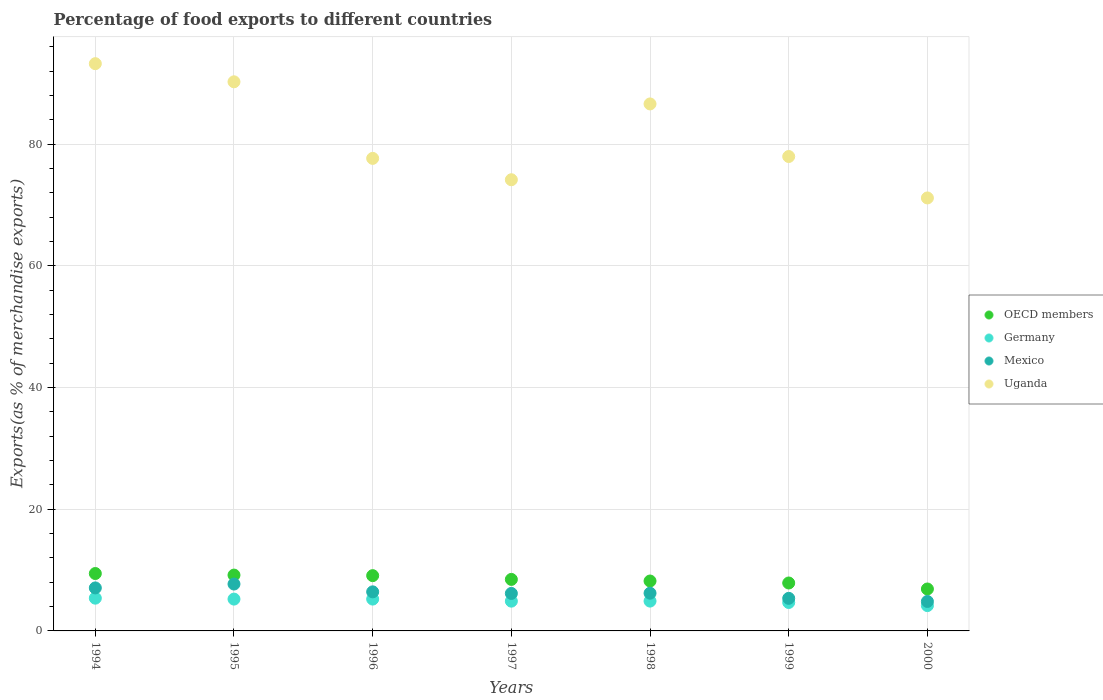How many different coloured dotlines are there?
Your response must be concise. 4. What is the percentage of exports to different countries in Germany in 2000?
Provide a succinct answer. 4.16. Across all years, what is the maximum percentage of exports to different countries in Germany?
Offer a very short reply. 5.38. Across all years, what is the minimum percentage of exports to different countries in Germany?
Offer a terse response. 4.16. What is the total percentage of exports to different countries in OECD members in the graph?
Provide a succinct answer. 59.15. What is the difference between the percentage of exports to different countries in OECD members in 1996 and that in 1998?
Keep it short and to the point. 0.88. What is the difference between the percentage of exports to different countries in Uganda in 1995 and the percentage of exports to different countries in OECD members in 2000?
Ensure brevity in your answer.  83.38. What is the average percentage of exports to different countries in Germany per year?
Keep it short and to the point. 4.93. In the year 1994, what is the difference between the percentage of exports to different countries in Germany and percentage of exports to different countries in Uganda?
Your answer should be compact. -87.87. In how many years, is the percentage of exports to different countries in Mexico greater than 92 %?
Ensure brevity in your answer.  0. What is the ratio of the percentage of exports to different countries in OECD members in 1996 to that in 1999?
Your answer should be compact. 1.15. What is the difference between the highest and the second highest percentage of exports to different countries in OECD members?
Your answer should be compact. 0.26. What is the difference between the highest and the lowest percentage of exports to different countries in OECD members?
Provide a succinct answer. 2.54. In how many years, is the percentage of exports to different countries in Germany greater than the average percentage of exports to different countries in Germany taken over all years?
Give a very brief answer. 3. Is it the case that in every year, the sum of the percentage of exports to different countries in OECD members and percentage of exports to different countries in Uganda  is greater than the sum of percentage of exports to different countries in Germany and percentage of exports to different countries in Mexico?
Provide a succinct answer. No. Is the percentage of exports to different countries in Mexico strictly greater than the percentage of exports to different countries in OECD members over the years?
Keep it short and to the point. No. Is the percentage of exports to different countries in OECD members strictly less than the percentage of exports to different countries in Uganda over the years?
Offer a very short reply. Yes. How many dotlines are there?
Provide a succinct answer. 4. How many years are there in the graph?
Provide a succinct answer. 7. What is the difference between two consecutive major ticks on the Y-axis?
Keep it short and to the point. 20. Does the graph contain any zero values?
Your answer should be very brief. No. How many legend labels are there?
Keep it short and to the point. 4. What is the title of the graph?
Provide a short and direct response. Percentage of food exports to different countries. What is the label or title of the X-axis?
Offer a terse response. Years. What is the label or title of the Y-axis?
Your answer should be compact. Exports(as % of merchandise exports). What is the Exports(as % of merchandise exports) in OECD members in 1994?
Provide a short and direct response. 9.44. What is the Exports(as % of merchandise exports) in Germany in 1994?
Your answer should be compact. 5.38. What is the Exports(as % of merchandise exports) in Mexico in 1994?
Your answer should be compact. 7.07. What is the Exports(as % of merchandise exports) in Uganda in 1994?
Provide a succinct answer. 93.25. What is the Exports(as % of merchandise exports) of OECD members in 1995?
Give a very brief answer. 9.18. What is the Exports(as % of merchandise exports) in Germany in 1995?
Ensure brevity in your answer.  5.23. What is the Exports(as % of merchandise exports) in Mexico in 1995?
Offer a very short reply. 7.71. What is the Exports(as % of merchandise exports) in Uganda in 1995?
Provide a short and direct response. 90.27. What is the Exports(as % of merchandise exports) in OECD members in 1996?
Provide a succinct answer. 9.09. What is the Exports(as % of merchandise exports) of Germany in 1996?
Provide a succinct answer. 5.23. What is the Exports(as % of merchandise exports) in Mexico in 1996?
Your answer should be very brief. 6.42. What is the Exports(as % of merchandise exports) of Uganda in 1996?
Give a very brief answer. 77.68. What is the Exports(as % of merchandise exports) of OECD members in 1997?
Ensure brevity in your answer.  8.47. What is the Exports(as % of merchandise exports) in Germany in 1997?
Make the answer very short. 4.89. What is the Exports(as % of merchandise exports) in Mexico in 1997?
Provide a succinct answer. 6.16. What is the Exports(as % of merchandise exports) in Uganda in 1997?
Ensure brevity in your answer.  74.17. What is the Exports(as % of merchandise exports) of OECD members in 1998?
Give a very brief answer. 8.2. What is the Exports(as % of merchandise exports) of Germany in 1998?
Ensure brevity in your answer.  4.9. What is the Exports(as % of merchandise exports) of Mexico in 1998?
Provide a succinct answer. 6.2. What is the Exports(as % of merchandise exports) of Uganda in 1998?
Keep it short and to the point. 86.64. What is the Exports(as % of merchandise exports) in OECD members in 1999?
Provide a succinct answer. 7.88. What is the Exports(as % of merchandise exports) of Germany in 1999?
Give a very brief answer. 4.67. What is the Exports(as % of merchandise exports) of Mexico in 1999?
Your response must be concise. 5.36. What is the Exports(as % of merchandise exports) in Uganda in 1999?
Your response must be concise. 77.99. What is the Exports(as % of merchandise exports) of OECD members in 2000?
Provide a short and direct response. 6.89. What is the Exports(as % of merchandise exports) of Germany in 2000?
Offer a very short reply. 4.16. What is the Exports(as % of merchandise exports) of Mexico in 2000?
Keep it short and to the point. 4.84. What is the Exports(as % of merchandise exports) of Uganda in 2000?
Give a very brief answer. 71.18. Across all years, what is the maximum Exports(as % of merchandise exports) of OECD members?
Your answer should be compact. 9.44. Across all years, what is the maximum Exports(as % of merchandise exports) in Germany?
Your response must be concise. 5.38. Across all years, what is the maximum Exports(as % of merchandise exports) in Mexico?
Give a very brief answer. 7.71. Across all years, what is the maximum Exports(as % of merchandise exports) in Uganda?
Your answer should be very brief. 93.25. Across all years, what is the minimum Exports(as % of merchandise exports) of OECD members?
Offer a very short reply. 6.89. Across all years, what is the minimum Exports(as % of merchandise exports) of Germany?
Keep it short and to the point. 4.16. Across all years, what is the minimum Exports(as % of merchandise exports) of Mexico?
Provide a succinct answer. 4.84. Across all years, what is the minimum Exports(as % of merchandise exports) in Uganda?
Ensure brevity in your answer.  71.18. What is the total Exports(as % of merchandise exports) of OECD members in the graph?
Ensure brevity in your answer.  59.15. What is the total Exports(as % of merchandise exports) in Germany in the graph?
Provide a short and direct response. 34.48. What is the total Exports(as % of merchandise exports) of Mexico in the graph?
Give a very brief answer. 43.76. What is the total Exports(as % of merchandise exports) in Uganda in the graph?
Offer a very short reply. 571.19. What is the difference between the Exports(as % of merchandise exports) in OECD members in 1994 and that in 1995?
Offer a very short reply. 0.26. What is the difference between the Exports(as % of merchandise exports) in Germany in 1994 and that in 1995?
Keep it short and to the point. 0.15. What is the difference between the Exports(as % of merchandise exports) of Mexico in 1994 and that in 1995?
Make the answer very short. -0.64. What is the difference between the Exports(as % of merchandise exports) of Uganda in 1994 and that in 1995?
Ensure brevity in your answer.  2.98. What is the difference between the Exports(as % of merchandise exports) in OECD members in 1994 and that in 1996?
Provide a short and direct response. 0.35. What is the difference between the Exports(as % of merchandise exports) in Germany in 1994 and that in 1996?
Ensure brevity in your answer.  0.15. What is the difference between the Exports(as % of merchandise exports) of Mexico in 1994 and that in 1996?
Ensure brevity in your answer.  0.65. What is the difference between the Exports(as % of merchandise exports) of Uganda in 1994 and that in 1996?
Provide a succinct answer. 15.57. What is the difference between the Exports(as % of merchandise exports) of OECD members in 1994 and that in 1997?
Your answer should be very brief. 0.97. What is the difference between the Exports(as % of merchandise exports) of Germany in 1994 and that in 1997?
Keep it short and to the point. 0.49. What is the difference between the Exports(as % of merchandise exports) of Mexico in 1994 and that in 1997?
Provide a short and direct response. 0.91. What is the difference between the Exports(as % of merchandise exports) of Uganda in 1994 and that in 1997?
Offer a terse response. 19.08. What is the difference between the Exports(as % of merchandise exports) in OECD members in 1994 and that in 1998?
Offer a very short reply. 1.23. What is the difference between the Exports(as % of merchandise exports) in Germany in 1994 and that in 1998?
Make the answer very short. 0.48. What is the difference between the Exports(as % of merchandise exports) in Mexico in 1994 and that in 1998?
Ensure brevity in your answer.  0.87. What is the difference between the Exports(as % of merchandise exports) of Uganda in 1994 and that in 1998?
Keep it short and to the point. 6.62. What is the difference between the Exports(as % of merchandise exports) of OECD members in 1994 and that in 1999?
Provide a succinct answer. 1.56. What is the difference between the Exports(as % of merchandise exports) in Germany in 1994 and that in 1999?
Ensure brevity in your answer.  0.71. What is the difference between the Exports(as % of merchandise exports) of Mexico in 1994 and that in 1999?
Provide a succinct answer. 1.71. What is the difference between the Exports(as % of merchandise exports) in Uganda in 1994 and that in 1999?
Provide a short and direct response. 15.26. What is the difference between the Exports(as % of merchandise exports) of OECD members in 1994 and that in 2000?
Provide a succinct answer. 2.54. What is the difference between the Exports(as % of merchandise exports) in Germany in 1994 and that in 2000?
Make the answer very short. 1.22. What is the difference between the Exports(as % of merchandise exports) of Mexico in 1994 and that in 2000?
Your response must be concise. 2.23. What is the difference between the Exports(as % of merchandise exports) of Uganda in 1994 and that in 2000?
Your response must be concise. 22.08. What is the difference between the Exports(as % of merchandise exports) in OECD members in 1995 and that in 1996?
Provide a succinct answer. 0.09. What is the difference between the Exports(as % of merchandise exports) in Germany in 1995 and that in 1996?
Your response must be concise. -0. What is the difference between the Exports(as % of merchandise exports) in Mexico in 1995 and that in 1996?
Provide a short and direct response. 1.28. What is the difference between the Exports(as % of merchandise exports) of Uganda in 1995 and that in 1996?
Your answer should be very brief. 12.59. What is the difference between the Exports(as % of merchandise exports) of OECD members in 1995 and that in 1997?
Ensure brevity in your answer.  0.71. What is the difference between the Exports(as % of merchandise exports) of Germany in 1995 and that in 1997?
Give a very brief answer. 0.34. What is the difference between the Exports(as % of merchandise exports) in Mexico in 1995 and that in 1997?
Offer a terse response. 1.54. What is the difference between the Exports(as % of merchandise exports) in Uganda in 1995 and that in 1997?
Ensure brevity in your answer.  16.1. What is the difference between the Exports(as % of merchandise exports) of OECD members in 1995 and that in 1998?
Ensure brevity in your answer.  0.97. What is the difference between the Exports(as % of merchandise exports) of Germany in 1995 and that in 1998?
Your response must be concise. 0.33. What is the difference between the Exports(as % of merchandise exports) in Mexico in 1995 and that in 1998?
Make the answer very short. 1.51. What is the difference between the Exports(as % of merchandise exports) of Uganda in 1995 and that in 1998?
Your response must be concise. 3.64. What is the difference between the Exports(as % of merchandise exports) in OECD members in 1995 and that in 1999?
Provide a short and direct response. 1.3. What is the difference between the Exports(as % of merchandise exports) in Germany in 1995 and that in 1999?
Provide a succinct answer. 0.56. What is the difference between the Exports(as % of merchandise exports) of Mexico in 1995 and that in 1999?
Provide a short and direct response. 2.35. What is the difference between the Exports(as % of merchandise exports) of Uganda in 1995 and that in 1999?
Your answer should be compact. 12.28. What is the difference between the Exports(as % of merchandise exports) in OECD members in 1995 and that in 2000?
Your answer should be very brief. 2.28. What is the difference between the Exports(as % of merchandise exports) in Germany in 1995 and that in 2000?
Your answer should be very brief. 1.07. What is the difference between the Exports(as % of merchandise exports) in Mexico in 1995 and that in 2000?
Your answer should be compact. 2.86. What is the difference between the Exports(as % of merchandise exports) in Uganda in 1995 and that in 2000?
Give a very brief answer. 19.09. What is the difference between the Exports(as % of merchandise exports) of OECD members in 1996 and that in 1997?
Provide a short and direct response. 0.62. What is the difference between the Exports(as % of merchandise exports) of Germany in 1996 and that in 1997?
Keep it short and to the point. 0.34. What is the difference between the Exports(as % of merchandise exports) in Mexico in 1996 and that in 1997?
Your response must be concise. 0.26. What is the difference between the Exports(as % of merchandise exports) of Uganda in 1996 and that in 1997?
Your answer should be compact. 3.51. What is the difference between the Exports(as % of merchandise exports) of OECD members in 1996 and that in 1998?
Your answer should be very brief. 0.88. What is the difference between the Exports(as % of merchandise exports) in Germany in 1996 and that in 1998?
Your response must be concise. 0.33. What is the difference between the Exports(as % of merchandise exports) in Mexico in 1996 and that in 1998?
Your answer should be compact. 0.22. What is the difference between the Exports(as % of merchandise exports) of Uganda in 1996 and that in 1998?
Give a very brief answer. -8.95. What is the difference between the Exports(as % of merchandise exports) in OECD members in 1996 and that in 1999?
Provide a succinct answer. 1.21. What is the difference between the Exports(as % of merchandise exports) of Germany in 1996 and that in 1999?
Your response must be concise. 0.56. What is the difference between the Exports(as % of merchandise exports) in Mexico in 1996 and that in 1999?
Offer a very short reply. 1.07. What is the difference between the Exports(as % of merchandise exports) of Uganda in 1996 and that in 1999?
Offer a very short reply. -0.31. What is the difference between the Exports(as % of merchandise exports) of OECD members in 1996 and that in 2000?
Provide a succinct answer. 2.19. What is the difference between the Exports(as % of merchandise exports) of Germany in 1996 and that in 2000?
Offer a very short reply. 1.07. What is the difference between the Exports(as % of merchandise exports) of Mexico in 1996 and that in 2000?
Provide a short and direct response. 1.58. What is the difference between the Exports(as % of merchandise exports) in Uganda in 1996 and that in 2000?
Your response must be concise. 6.5. What is the difference between the Exports(as % of merchandise exports) of OECD members in 1997 and that in 1998?
Your response must be concise. 0.26. What is the difference between the Exports(as % of merchandise exports) in Germany in 1997 and that in 1998?
Keep it short and to the point. -0.01. What is the difference between the Exports(as % of merchandise exports) in Mexico in 1997 and that in 1998?
Offer a terse response. -0.04. What is the difference between the Exports(as % of merchandise exports) in Uganda in 1997 and that in 1998?
Your answer should be compact. -12.46. What is the difference between the Exports(as % of merchandise exports) in OECD members in 1997 and that in 1999?
Ensure brevity in your answer.  0.59. What is the difference between the Exports(as % of merchandise exports) in Germany in 1997 and that in 1999?
Give a very brief answer. 0.22. What is the difference between the Exports(as % of merchandise exports) of Mexico in 1997 and that in 1999?
Your answer should be very brief. 0.81. What is the difference between the Exports(as % of merchandise exports) of Uganda in 1997 and that in 1999?
Make the answer very short. -3.82. What is the difference between the Exports(as % of merchandise exports) in OECD members in 1997 and that in 2000?
Provide a succinct answer. 1.57. What is the difference between the Exports(as % of merchandise exports) in Germany in 1997 and that in 2000?
Offer a very short reply. 0.73. What is the difference between the Exports(as % of merchandise exports) in Mexico in 1997 and that in 2000?
Your answer should be very brief. 1.32. What is the difference between the Exports(as % of merchandise exports) of Uganda in 1997 and that in 2000?
Keep it short and to the point. 2.99. What is the difference between the Exports(as % of merchandise exports) of OECD members in 1998 and that in 1999?
Your answer should be very brief. 0.33. What is the difference between the Exports(as % of merchandise exports) in Germany in 1998 and that in 1999?
Give a very brief answer. 0.23. What is the difference between the Exports(as % of merchandise exports) in Mexico in 1998 and that in 1999?
Provide a succinct answer. 0.84. What is the difference between the Exports(as % of merchandise exports) of Uganda in 1998 and that in 1999?
Your answer should be very brief. 8.65. What is the difference between the Exports(as % of merchandise exports) in OECD members in 1998 and that in 2000?
Offer a very short reply. 1.31. What is the difference between the Exports(as % of merchandise exports) in Germany in 1998 and that in 2000?
Offer a terse response. 0.74. What is the difference between the Exports(as % of merchandise exports) in Mexico in 1998 and that in 2000?
Give a very brief answer. 1.36. What is the difference between the Exports(as % of merchandise exports) of Uganda in 1998 and that in 2000?
Make the answer very short. 15.46. What is the difference between the Exports(as % of merchandise exports) in OECD members in 1999 and that in 2000?
Ensure brevity in your answer.  0.99. What is the difference between the Exports(as % of merchandise exports) in Germany in 1999 and that in 2000?
Your response must be concise. 0.51. What is the difference between the Exports(as % of merchandise exports) in Mexico in 1999 and that in 2000?
Your answer should be very brief. 0.51. What is the difference between the Exports(as % of merchandise exports) of Uganda in 1999 and that in 2000?
Give a very brief answer. 6.81. What is the difference between the Exports(as % of merchandise exports) in OECD members in 1994 and the Exports(as % of merchandise exports) in Germany in 1995?
Keep it short and to the point. 4.2. What is the difference between the Exports(as % of merchandise exports) of OECD members in 1994 and the Exports(as % of merchandise exports) of Mexico in 1995?
Your response must be concise. 1.73. What is the difference between the Exports(as % of merchandise exports) in OECD members in 1994 and the Exports(as % of merchandise exports) in Uganda in 1995?
Your answer should be very brief. -80.84. What is the difference between the Exports(as % of merchandise exports) of Germany in 1994 and the Exports(as % of merchandise exports) of Mexico in 1995?
Keep it short and to the point. -2.32. What is the difference between the Exports(as % of merchandise exports) of Germany in 1994 and the Exports(as % of merchandise exports) of Uganda in 1995?
Offer a terse response. -84.89. What is the difference between the Exports(as % of merchandise exports) of Mexico in 1994 and the Exports(as % of merchandise exports) of Uganda in 1995?
Keep it short and to the point. -83.2. What is the difference between the Exports(as % of merchandise exports) of OECD members in 1994 and the Exports(as % of merchandise exports) of Germany in 1996?
Your answer should be compact. 4.2. What is the difference between the Exports(as % of merchandise exports) of OECD members in 1994 and the Exports(as % of merchandise exports) of Mexico in 1996?
Give a very brief answer. 3.01. What is the difference between the Exports(as % of merchandise exports) in OECD members in 1994 and the Exports(as % of merchandise exports) in Uganda in 1996?
Offer a very short reply. -68.25. What is the difference between the Exports(as % of merchandise exports) in Germany in 1994 and the Exports(as % of merchandise exports) in Mexico in 1996?
Offer a very short reply. -1.04. What is the difference between the Exports(as % of merchandise exports) of Germany in 1994 and the Exports(as % of merchandise exports) of Uganda in 1996?
Ensure brevity in your answer.  -72.3. What is the difference between the Exports(as % of merchandise exports) in Mexico in 1994 and the Exports(as % of merchandise exports) in Uganda in 1996?
Provide a succinct answer. -70.62. What is the difference between the Exports(as % of merchandise exports) in OECD members in 1994 and the Exports(as % of merchandise exports) in Germany in 1997?
Offer a terse response. 4.54. What is the difference between the Exports(as % of merchandise exports) of OECD members in 1994 and the Exports(as % of merchandise exports) of Mexico in 1997?
Give a very brief answer. 3.27. What is the difference between the Exports(as % of merchandise exports) of OECD members in 1994 and the Exports(as % of merchandise exports) of Uganda in 1997?
Your response must be concise. -64.74. What is the difference between the Exports(as % of merchandise exports) in Germany in 1994 and the Exports(as % of merchandise exports) in Mexico in 1997?
Offer a very short reply. -0.78. What is the difference between the Exports(as % of merchandise exports) in Germany in 1994 and the Exports(as % of merchandise exports) in Uganda in 1997?
Ensure brevity in your answer.  -68.79. What is the difference between the Exports(as % of merchandise exports) of Mexico in 1994 and the Exports(as % of merchandise exports) of Uganda in 1997?
Keep it short and to the point. -67.1. What is the difference between the Exports(as % of merchandise exports) in OECD members in 1994 and the Exports(as % of merchandise exports) in Germany in 1998?
Your response must be concise. 4.53. What is the difference between the Exports(as % of merchandise exports) of OECD members in 1994 and the Exports(as % of merchandise exports) of Mexico in 1998?
Keep it short and to the point. 3.24. What is the difference between the Exports(as % of merchandise exports) of OECD members in 1994 and the Exports(as % of merchandise exports) of Uganda in 1998?
Make the answer very short. -77.2. What is the difference between the Exports(as % of merchandise exports) of Germany in 1994 and the Exports(as % of merchandise exports) of Mexico in 1998?
Your answer should be compact. -0.82. What is the difference between the Exports(as % of merchandise exports) in Germany in 1994 and the Exports(as % of merchandise exports) in Uganda in 1998?
Offer a very short reply. -81.25. What is the difference between the Exports(as % of merchandise exports) of Mexico in 1994 and the Exports(as % of merchandise exports) of Uganda in 1998?
Provide a short and direct response. -79.57. What is the difference between the Exports(as % of merchandise exports) of OECD members in 1994 and the Exports(as % of merchandise exports) of Germany in 1999?
Offer a very short reply. 4.76. What is the difference between the Exports(as % of merchandise exports) of OECD members in 1994 and the Exports(as % of merchandise exports) of Mexico in 1999?
Ensure brevity in your answer.  4.08. What is the difference between the Exports(as % of merchandise exports) of OECD members in 1994 and the Exports(as % of merchandise exports) of Uganda in 1999?
Keep it short and to the point. -68.56. What is the difference between the Exports(as % of merchandise exports) of Germany in 1994 and the Exports(as % of merchandise exports) of Mexico in 1999?
Ensure brevity in your answer.  0.03. What is the difference between the Exports(as % of merchandise exports) in Germany in 1994 and the Exports(as % of merchandise exports) in Uganda in 1999?
Your response must be concise. -72.61. What is the difference between the Exports(as % of merchandise exports) in Mexico in 1994 and the Exports(as % of merchandise exports) in Uganda in 1999?
Offer a very short reply. -70.92. What is the difference between the Exports(as % of merchandise exports) in OECD members in 1994 and the Exports(as % of merchandise exports) in Germany in 2000?
Provide a short and direct response. 5.27. What is the difference between the Exports(as % of merchandise exports) of OECD members in 1994 and the Exports(as % of merchandise exports) of Mexico in 2000?
Ensure brevity in your answer.  4.59. What is the difference between the Exports(as % of merchandise exports) of OECD members in 1994 and the Exports(as % of merchandise exports) of Uganda in 2000?
Offer a terse response. -61.74. What is the difference between the Exports(as % of merchandise exports) of Germany in 1994 and the Exports(as % of merchandise exports) of Mexico in 2000?
Ensure brevity in your answer.  0.54. What is the difference between the Exports(as % of merchandise exports) in Germany in 1994 and the Exports(as % of merchandise exports) in Uganda in 2000?
Provide a succinct answer. -65.8. What is the difference between the Exports(as % of merchandise exports) in Mexico in 1994 and the Exports(as % of merchandise exports) in Uganda in 2000?
Offer a terse response. -64.11. What is the difference between the Exports(as % of merchandise exports) of OECD members in 1995 and the Exports(as % of merchandise exports) of Germany in 1996?
Offer a very short reply. 3.94. What is the difference between the Exports(as % of merchandise exports) in OECD members in 1995 and the Exports(as % of merchandise exports) in Mexico in 1996?
Ensure brevity in your answer.  2.76. What is the difference between the Exports(as % of merchandise exports) in OECD members in 1995 and the Exports(as % of merchandise exports) in Uganda in 1996?
Ensure brevity in your answer.  -68.51. What is the difference between the Exports(as % of merchandise exports) in Germany in 1995 and the Exports(as % of merchandise exports) in Mexico in 1996?
Make the answer very short. -1.19. What is the difference between the Exports(as % of merchandise exports) of Germany in 1995 and the Exports(as % of merchandise exports) of Uganda in 1996?
Your answer should be very brief. -72.45. What is the difference between the Exports(as % of merchandise exports) of Mexico in 1995 and the Exports(as % of merchandise exports) of Uganda in 1996?
Your answer should be compact. -69.98. What is the difference between the Exports(as % of merchandise exports) of OECD members in 1995 and the Exports(as % of merchandise exports) of Germany in 1997?
Provide a succinct answer. 4.28. What is the difference between the Exports(as % of merchandise exports) in OECD members in 1995 and the Exports(as % of merchandise exports) in Mexico in 1997?
Make the answer very short. 3.02. What is the difference between the Exports(as % of merchandise exports) of OECD members in 1995 and the Exports(as % of merchandise exports) of Uganda in 1997?
Ensure brevity in your answer.  -64.99. What is the difference between the Exports(as % of merchandise exports) of Germany in 1995 and the Exports(as % of merchandise exports) of Mexico in 1997?
Give a very brief answer. -0.93. What is the difference between the Exports(as % of merchandise exports) of Germany in 1995 and the Exports(as % of merchandise exports) of Uganda in 1997?
Make the answer very short. -68.94. What is the difference between the Exports(as % of merchandise exports) in Mexico in 1995 and the Exports(as % of merchandise exports) in Uganda in 1997?
Provide a short and direct response. -66.47. What is the difference between the Exports(as % of merchandise exports) in OECD members in 1995 and the Exports(as % of merchandise exports) in Germany in 1998?
Provide a succinct answer. 4.28. What is the difference between the Exports(as % of merchandise exports) in OECD members in 1995 and the Exports(as % of merchandise exports) in Mexico in 1998?
Ensure brevity in your answer.  2.98. What is the difference between the Exports(as % of merchandise exports) of OECD members in 1995 and the Exports(as % of merchandise exports) of Uganda in 1998?
Your answer should be compact. -77.46. What is the difference between the Exports(as % of merchandise exports) in Germany in 1995 and the Exports(as % of merchandise exports) in Mexico in 1998?
Your response must be concise. -0.97. What is the difference between the Exports(as % of merchandise exports) in Germany in 1995 and the Exports(as % of merchandise exports) in Uganda in 1998?
Offer a terse response. -81.41. What is the difference between the Exports(as % of merchandise exports) of Mexico in 1995 and the Exports(as % of merchandise exports) of Uganda in 1998?
Offer a very short reply. -78.93. What is the difference between the Exports(as % of merchandise exports) of OECD members in 1995 and the Exports(as % of merchandise exports) of Germany in 1999?
Keep it short and to the point. 4.5. What is the difference between the Exports(as % of merchandise exports) in OECD members in 1995 and the Exports(as % of merchandise exports) in Mexico in 1999?
Make the answer very short. 3.82. What is the difference between the Exports(as % of merchandise exports) in OECD members in 1995 and the Exports(as % of merchandise exports) in Uganda in 1999?
Provide a short and direct response. -68.81. What is the difference between the Exports(as % of merchandise exports) in Germany in 1995 and the Exports(as % of merchandise exports) in Mexico in 1999?
Your answer should be very brief. -0.12. What is the difference between the Exports(as % of merchandise exports) of Germany in 1995 and the Exports(as % of merchandise exports) of Uganda in 1999?
Your response must be concise. -72.76. What is the difference between the Exports(as % of merchandise exports) in Mexico in 1995 and the Exports(as % of merchandise exports) in Uganda in 1999?
Offer a very short reply. -70.28. What is the difference between the Exports(as % of merchandise exports) in OECD members in 1995 and the Exports(as % of merchandise exports) in Germany in 2000?
Offer a terse response. 5.02. What is the difference between the Exports(as % of merchandise exports) in OECD members in 1995 and the Exports(as % of merchandise exports) in Mexico in 2000?
Provide a succinct answer. 4.34. What is the difference between the Exports(as % of merchandise exports) of OECD members in 1995 and the Exports(as % of merchandise exports) of Uganda in 2000?
Your response must be concise. -62. What is the difference between the Exports(as % of merchandise exports) in Germany in 1995 and the Exports(as % of merchandise exports) in Mexico in 2000?
Offer a very short reply. 0.39. What is the difference between the Exports(as % of merchandise exports) of Germany in 1995 and the Exports(as % of merchandise exports) of Uganda in 2000?
Provide a succinct answer. -65.95. What is the difference between the Exports(as % of merchandise exports) in Mexico in 1995 and the Exports(as % of merchandise exports) in Uganda in 2000?
Your response must be concise. -63.47. What is the difference between the Exports(as % of merchandise exports) in OECD members in 1996 and the Exports(as % of merchandise exports) in Germany in 1997?
Keep it short and to the point. 4.19. What is the difference between the Exports(as % of merchandise exports) in OECD members in 1996 and the Exports(as % of merchandise exports) in Mexico in 1997?
Your answer should be very brief. 2.92. What is the difference between the Exports(as % of merchandise exports) of OECD members in 1996 and the Exports(as % of merchandise exports) of Uganda in 1997?
Keep it short and to the point. -65.08. What is the difference between the Exports(as % of merchandise exports) in Germany in 1996 and the Exports(as % of merchandise exports) in Mexico in 1997?
Make the answer very short. -0.93. What is the difference between the Exports(as % of merchandise exports) of Germany in 1996 and the Exports(as % of merchandise exports) of Uganda in 1997?
Your answer should be compact. -68.94. What is the difference between the Exports(as % of merchandise exports) of Mexico in 1996 and the Exports(as % of merchandise exports) of Uganda in 1997?
Provide a succinct answer. -67.75. What is the difference between the Exports(as % of merchandise exports) in OECD members in 1996 and the Exports(as % of merchandise exports) in Germany in 1998?
Ensure brevity in your answer.  4.19. What is the difference between the Exports(as % of merchandise exports) of OECD members in 1996 and the Exports(as % of merchandise exports) of Mexico in 1998?
Ensure brevity in your answer.  2.89. What is the difference between the Exports(as % of merchandise exports) of OECD members in 1996 and the Exports(as % of merchandise exports) of Uganda in 1998?
Your response must be concise. -77.55. What is the difference between the Exports(as % of merchandise exports) of Germany in 1996 and the Exports(as % of merchandise exports) of Mexico in 1998?
Your response must be concise. -0.97. What is the difference between the Exports(as % of merchandise exports) of Germany in 1996 and the Exports(as % of merchandise exports) of Uganda in 1998?
Ensure brevity in your answer.  -81.4. What is the difference between the Exports(as % of merchandise exports) in Mexico in 1996 and the Exports(as % of merchandise exports) in Uganda in 1998?
Your response must be concise. -80.21. What is the difference between the Exports(as % of merchandise exports) in OECD members in 1996 and the Exports(as % of merchandise exports) in Germany in 1999?
Give a very brief answer. 4.41. What is the difference between the Exports(as % of merchandise exports) of OECD members in 1996 and the Exports(as % of merchandise exports) of Mexico in 1999?
Your response must be concise. 3.73. What is the difference between the Exports(as % of merchandise exports) in OECD members in 1996 and the Exports(as % of merchandise exports) in Uganda in 1999?
Offer a terse response. -68.9. What is the difference between the Exports(as % of merchandise exports) of Germany in 1996 and the Exports(as % of merchandise exports) of Mexico in 1999?
Provide a succinct answer. -0.12. What is the difference between the Exports(as % of merchandise exports) in Germany in 1996 and the Exports(as % of merchandise exports) in Uganda in 1999?
Ensure brevity in your answer.  -72.76. What is the difference between the Exports(as % of merchandise exports) of Mexico in 1996 and the Exports(as % of merchandise exports) of Uganda in 1999?
Ensure brevity in your answer.  -71.57. What is the difference between the Exports(as % of merchandise exports) in OECD members in 1996 and the Exports(as % of merchandise exports) in Germany in 2000?
Offer a very short reply. 4.92. What is the difference between the Exports(as % of merchandise exports) in OECD members in 1996 and the Exports(as % of merchandise exports) in Mexico in 2000?
Provide a succinct answer. 4.24. What is the difference between the Exports(as % of merchandise exports) in OECD members in 1996 and the Exports(as % of merchandise exports) in Uganda in 2000?
Make the answer very short. -62.09. What is the difference between the Exports(as % of merchandise exports) of Germany in 1996 and the Exports(as % of merchandise exports) of Mexico in 2000?
Your answer should be compact. 0.39. What is the difference between the Exports(as % of merchandise exports) in Germany in 1996 and the Exports(as % of merchandise exports) in Uganda in 2000?
Ensure brevity in your answer.  -65.95. What is the difference between the Exports(as % of merchandise exports) in Mexico in 1996 and the Exports(as % of merchandise exports) in Uganda in 2000?
Provide a short and direct response. -64.76. What is the difference between the Exports(as % of merchandise exports) in OECD members in 1997 and the Exports(as % of merchandise exports) in Germany in 1998?
Your answer should be very brief. 3.57. What is the difference between the Exports(as % of merchandise exports) in OECD members in 1997 and the Exports(as % of merchandise exports) in Mexico in 1998?
Provide a short and direct response. 2.27. What is the difference between the Exports(as % of merchandise exports) of OECD members in 1997 and the Exports(as % of merchandise exports) of Uganda in 1998?
Make the answer very short. -78.17. What is the difference between the Exports(as % of merchandise exports) in Germany in 1997 and the Exports(as % of merchandise exports) in Mexico in 1998?
Make the answer very short. -1.31. What is the difference between the Exports(as % of merchandise exports) in Germany in 1997 and the Exports(as % of merchandise exports) in Uganda in 1998?
Your answer should be compact. -81.74. What is the difference between the Exports(as % of merchandise exports) of Mexico in 1997 and the Exports(as % of merchandise exports) of Uganda in 1998?
Your answer should be compact. -80.47. What is the difference between the Exports(as % of merchandise exports) of OECD members in 1997 and the Exports(as % of merchandise exports) of Germany in 1999?
Your answer should be compact. 3.79. What is the difference between the Exports(as % of merchandise exports) in OECD members in 1997 and the Exports(as % of merchandise exports) in Mexico in 1999?
Offer a very short reply. 3.11. What is the difference between the Exports(as % of merchandise exports) in OECD members in 1997 and the Exports(as % of merchandise exports) in Uganda in 1999?
Offer a very short reply. -69.52. What is the difference between the Exports(as % of merchandise exports) of Germany in 1997 and the Exports(as % of merchandise exports) of Mexico in 1999?
Provide a short and direct response. -0.46. What is the difference between the Exports(as % of merchandise exports) of Germany in 1997 and the Exports(as % of merchandise exports) of Uganda in 1999?
Your answer should be very brief. -73.1. What is the difference between the Exports(as % of merchandise exports) of Mexico in 1997 and the Exports(as % of merchandise exports) of Uganda in 1999?
Your answer should be compact. -71.83. What is the difference between the Exports(as % of merchandise exports) of OECD members in 1997 and the Exports(as % of merchandise exports) of Germany in 2000?
Make the answer very short. 4.31. What is the difference between the Exports(as % of merchandise exports) in OECD members in 1997 and the Exports(as % of merchandise exports) in Mexico in 2000?
Provide a succinct answer. 3.63. What is the difference between the Exports(as % of merchandise exports) of OECD members in 1997 and the Exports(as % of merchandise exports) of Uganda in 2000?
Provide a short and direct response. -62.71. What is the difference between the Exports(as % of merchandise exports) of Germany in 1997 and the Exports(as % of merchandise exports) of Mexico in 2000?
Give a very brief answer. 0.05. What is the difference between the Exports(as % of merchandise exports) in Germany in 1997 and the Exports(as % of merchandise exports) in Uganda in 2000?
Your answer should be compact. -66.29. What is the difference between the Exports(as % of merchandise exports) in Mexico in 1997 and the Exports(as % of merchandise exports) in Uganda in 2000?
Give a very brief answer. -65.02. What is the difference between the Exports(as % of merchandise exports) in OECD members in 1998 and the Exports(as % of merchandise exports) in Germany in 1999?
Your answer should be very brief. 3.53. What is the difference between the Exports(as % of merchandise exports) in OECD members in 1998 and the Exports(as % of merchandise exports) in Mexico in 1999?
Provide a succinct answer. 2.85. What is the difference between the Exports(as % of merchandise exports) of OECD members in 1998 and the Exports(as % of merchandise exports) of Uganda in 1999?
Ensure brevity in your answer.  -69.79. What is the difference between the Exports(as % of merchandise exports) in Germany in 1998 and the Exports(as % of merchandise exports) in Mexico in 1999?
Offer a very short reply. -0.45. What is the difference between the Exports(as % of merchandise exports) of Germany in 1998 and the Exports(as % of merchandise exports) of Uganda in 1999?
Provide a succinct answer. -73.09. What is the difference between the Exports(as % of merchandise exports) in Mexico in 1998 and the Exports(as % of merchandise exports) in Uganda in 1999?
Your answer should be very brief. -71.79. What is the difference between the Exports(as % of merchandise exports) of OECD members in 1998 and the Exports(as % of merchandise exports) of Germany in 2000?
Make the answer very short. 4.04. What is the difference between the Exports(as % of merchandise exports) of OECD members in 1998 and the Exports(as % of merchandise exports) of Mexico in 2000?
Your answer should be very brief. 3.36. What is the difference between the Exports(as % of merchandise exports) in OECD members in 1998 and the Exports(as % of merchandise exports) in Uganda in 2000?
Make the answer very short. -62.97. What is the difference between the Exports(as % of merchandise exports) in Germany in 1998 and the Exports(as % of merchandise exports) in Mexico in 2000?
Provide a short and direct response. 0.06. What is the difference between the Exports(as % of merchandise exports) of Germany in 1998 and the Exports(as % of merchandise exports) of Uganda in 2000?
Your answer should be compact. -66.28. What is the difference between the Exports(as % of merchandise exports) of Mexico in 1998 and the Exports(as % of merchandise exports) of Uganda in 2000?
Give a very brief answer. -64.98. What is the difference between the Exports(as % of merchandise exports) of OECD members in 1999 and the Exports(as % of merchandise exports) of Germany in 2000?
Keep it short and to the point. 3.72. What is the difference between the Exports(as % of merchandise exports) of OECD members in 1999 and the Exports(as % of merchandise exports) of Mexico in 2000?
Give a very brief answer. 3.04. What is the difference between the Exports(as % of merchandise exports) in OECD members in 1999 and the Exports(as % of merchandise exports) in Uganda in 2000?
Keep it short and to the point. -63.3. What is the difference between the Exports(as % of merchandise exports) of Germany in 1999 and the Exports(as % of merchandise exports) of Mexico in 2000?
Offer a very short reply. -0.17. What is the difference between the Exports(as % of merchandise exports) in Germany in 1999 and the Exports(as % of merchandise exports) in Uganda in 2000?
Offer a terse response. -66.51. What is the difference between the Exports(as % of merchandise exports) in Mexico in 1999 and the Exports(as % of merchandise exports) in Uganda in 2000?
Your response must be concise. -65.82. What is the average Exports(as % of merchandise exports) in OECD members per year?
Provide a short and direct response. 8.45. What is the average Exports(as % of merchandise exports) of Germany per year?
Give a very brief answer. 4.93. What is the average Exports(as % of merchandise exports) in Mexico per year?
Keep it short and to the point. 6.25. What is the average Exports(as % of merchandise exports) in Uganda per year?
Ensure brevity in your answer.  81.6. In the year 1994, what is the difference between the Exports(as % of merchandise exports) of OECD members and Exports(as % of merchandise exports) of Germany?
Ensure brevity in your answer.  4.05. In the year 1994, what is the difference between the Exports(as % of merchandise exports) of OECD members and Exports(as % of merchandise exports) of Mexico?
Give a very brief answer. 2.37. In the year 1994, what is the difference between the Exports(as % of merchandise exports) in OECD members and Exports(as % of merchandise exports) in Uganda?
Provide a short and direct response. -83.82. In the year 1994, what is the difference between the Exports(as % of merchandise exports) in Germany and Exports(as % of merchandise exports) in Mexico?
Your answer should be compact. -1.69. In the year 1994, what is the difference between the Exports(as % of merchandise exports) of Germany and Exports(as % of merchandise exports) of Uganda?
Give a very brief answer. -87.87. In the year 1994, what is the difference between the Exports(as % of merchandise exports) in Mexico and Exports(as % of merchandise exports) in Uganda?
Offer a terse response. -86.19. In the year 1995, what is the difference between the Exports(as % of merchandise exports) in OECD members and Exports(as % of merchandise exports) in Germany?
Give a very brief answer. 3.95. In the year 1995, what is the difference between the Exports(as % of merchandise exports) in OECD members and Exports(as % of merchandise exports) in Mexico?
Give a very brief answer. 1.47. In the year 1995, what is the difference between the Exports(as % of merchandise exports) of OECD members and Exports(as % of merchandise exports) of Uganda?
Your answer should be very brief. -81.09. In the year 1995, what is the difference between the Exports(as % of merchandise exports) of Germany and Exports(as % of merchandise exports) of Mexico?
Keep it short and to the point. -2.48. In the year 1995, what is the difference between the Exports(as % of merchandise exports) of Germany and Exports(as % of merchandise exports) of Uganda?
Give a very brief answer. -85.04. In the year 1995, what is the difference between the Exports(as % of merchandise exports) in Mexico and Exports(as % of merchandise exports) in Uganda?
Make the answer very short. -82.57. In the year 1996, what is the difference between the Exports(as % of merchandise exports) of OECD members and Exports(as % of merchandise exports) of Germany?
Provide a succinct answer. 3.85. In the year 1996, what is the difference between the Exports(as % of merchandise exports) in OECD members and Exports(as % of merchandise exports) in Mexico?
Offer a terse response. 2.66. In the year 1996, what is the difference between the Exports(as % of merchandise exports) in OECD members and Exports(as % of merchandise exports) in Uganda?
Provide a short and direct response. -68.6. In the year 1996, what is the difference between the Exports(as % of merchandise exports) of Germany and Exports(as % of merchandise exports) of Mexico?
Your answer should be compact. -1.19. In the year 1996, what is the difference between the Exports(as % of merchandise exports) in Germany and Exports(as % of merchandise exports) in Uganda?
Give a very brief answer. -72.45. In the year 1996, what is the difference between the Exports(as % of merchandise exports) of Mexico and Exports(as % of merchandise exports) of Uganda?
Keep it short and to the point. -71.26. In the year 1997, what is the difference between the Exports(as % of merchandise exports) in OECD members and Exports(as % of merchandise exports) in Germany?
Ensure brevity in your answer.  3.57. In the year 1997, what is the difference between the Exports(as % of merchandise exports) of OECD members and Exports(as % of merchandise exports) of Mexico?
Make the answer very short. 2.31. In the year 1997, what is the difference between the Exports(as % of merchandise exports) of OECD members and Exports(as % of merchandise exports) of Uganda?
Provide a short and direct response. -65.7. In the year 1997, what is the difference between the Exports(as % of merchandise exports) in Germany and Exports(as % of merchandise exports) in Mexico?
Your response must be concise. -1.27. In the year 1997, what is the difference between the Exports(as % of merchandise exports) of Germany and Exports(as % of merchandise exports) of Uganda?
Your response must be concise. -69.28. In the year 1997, what is the difference between the Exports(as % of merchandise exports) in Mexico and Exports(as % of merchandise exports) in Uganda?
Ensure brevity in your answer.  -68.01. In the year 1998, what is the difference between the Exports(as % of merchandise exports) in OECD members and Exports(as % of merchandise exports) in Germany?
Offer a terse response. 3.3. In the year 1998, what is the difference between the Exports(as % of merchandise exports) in OECD members and Exports(as % of merchandise exports) in Mexico?
Give a very brief answer. 2. In the year 1998, what is the difference between the Exports(as % of merchandise exports) of OECD members and Exports(as % of merchandise exports) of Uganda?
Your response must be concise. -78.43. In the year 1998, what is the difference between the Exports(as % of merchandise exports) in Germany and Exports(as % of merchandise exports) in Mexico?
Offer a terse response. -1.3. In the year 1998, what is the difference between the Exports(as % of merchandise exports) in Germany and Exports(as % of merchandise exports) in Uganda?
Keep it short and to the point. -81.73. In the year 1998, what is the difference between the Exports(as % of merchandise exports) of Mexico and Exports(as % of merchandise exports) of Uganda?
Provide a short and direct response. -80.44. In the year 1999, what is the difference between the Exports(as % of merchandise exports) in OECD members and Exports(as % of merchandise exports) in Germany?
Make the answer very short. 3.21. In the year 1999, what is the difference between the Exports(as % of merchandise exports) in OECD members and Exports(as % of merchandise exports) in Mexico?
Keep it short and to the point. 2.52. In the year 1999, what is the difference between the Exports(as % of merchandise exports) of OECD members and Exports(as % of merchandise exports) of Uganda?
Provide a succinct answer. -70.11. In the year 1999, what is the difference between the Exports(as % of merchandise exports) in Germany and Exports(as % of merchandise exports) in Mexico?
Keep it short and to the point. -0.68. In the year 1999, what is the difference between the Exports(as % of merchandise exports) in Germany and Exports(as % of merchandise exports) in Uganda?
Offer a terse response. -73.32. In the year 1999, what is the difference between the Exports(as % of merchandise exports) of Mexico and Exports(as % of merchandise exports) of Uganda?
Your answer should be very brief. -72.64. In the year 2000, what is the difference between the Exports(as % of merchandise exports) in OECD members and Exports(as % of merchandise exports) in Germany?
Offer a terse response. 2.73. In the year 2000, what is the difference between the Exports(as % of merchandise exports) of OECD members and Exports(as % of merchandise exports) of Mexico?
Provide a succinct answer. 2.05. In the year 2000, what is the difference between the Exports(as % of merchandise exports) in OECD members and Exports(as % of merchandise exports) in Uganda?
Keep it short and to the point. -64.29. In the year 2000, what is the difference between the Exports(as % of merchandise exports) in Germany and Exports(as % of merchandise exports) in Mexico?
Ensure brevity in your answer.  -0.68. In the year 2000, what is the difference between the Exports(as % of merchandise exports) in Germany and Exports(as % of merchandise exports) in Uganda?
Your answer should be very brief. -67.02. In the year 2000, what is the difference between the Exports(as % of merchandise exports) in Mexico and Exports(as % of merchandise exports) in Uganda?
Make the answer very short. -66.34. What is the ratio of the Exports(as % of merchandise exports) of OECD members in 1994 to that in 1995?
Give a very brief answer. 1.03. What is the ratio of the Exports(as % of merchandise exports) in Germany in 1994 to that in 1995?
Give a very brief answer. 1.03. What is the ratio of the Exports(as % of merchandise exports) of Mexico in 1994 to that in 1995?
Offer a terse response. 0.92. What is the ratio of the Exports(as % of merchandise exports) in Uganda in 1994 to that in 1995?
Your response must be concise. 1.03. What is the ratio of the Exports(as % of merchandise exports) in OECD members in 1994 to that in 1996?
Ensure brevity in your answer.  1.04. What is the ratio of the Exports(as % of merchandise exports) in Germany in 1994 to that in 1996?
Your response must be concise. 1.03. What is the ratio of the Exports(as % of merchandise exports) of Mexico in 1994 to that in 1996?
Offer a very short reply. 1.1. What is the ratio of the Exports(as % of merchandise exports) in Uganda in 1994 to that in 1996?
Your answer should be very brief. 1.2. What is the ratio of the Exports(as % of merchandise exports) of OECD members in 1994 to that in 1997?
Give a very brief answer. 1.11. What is the ratio of the Exports(as % of merchandise exports) in Germany in 1994 to that in 1997?
Offer a very short reply. 1.1. What is the ratio of the Exports(as % of merchandise exports) of Mexico in 1994 to that in 1997?
Your answer should be very brief. 1.15. What is the ratio of the Exports(as % of merchandise exports) of Uganda in 1994 to that in 1997?
Give a very brief answer. 1.26. What is the ratio of the Exports(as % of merchandise exports) in OECD members in 1994 to that in 1998?
Provide a short and direct response. 1.15. What is the ratio of the Exports(as % of merchandise exports) of Germany in 1994 to that in 1998?
Offer a terse response. 1.1. What is the ratio of the Exports(as % of merchandise exports) of Mexico in 1994 to that in 1998?
Provide a succinct answer. 1.14. What is the ratio of the Exports(as % of merchandise exports) in Uganda in 1994 to that in 1998?
Your answer should be very brief. 1.08. What is the ratio of the Exports(as % of merchandise exports) in OECD members in 1994 to that in 1999?
Offer a terse response. 1.2. What is the ratio of the Exports(as % of merchandise exports) of Germany in 1994 to that in 1999?
Your answer should be very brief. 1.15. What is the ratio of the Exports(as % of merchandise exports) of Mexico in 1994 to that in 1999?
Provide a succinct answer. 1.32. What is the ratio of the Exports(as % of merchandise exports) in Uganda in 1994 to that in 1999?
Offer a very short reply. 1.2. What is the ratio of the Exports(as % of merchandise exports) in OECD members in 1994 to that in 2000?
Offer a terse response. 1.37. What is the ratio of the Exports(as % of merchandise exports) of Germany in 1994 to that in 2000?
Your answer should be compact. 1.29. What is the ratio of the Exports(as % of merchandise exports) in Mexico in 1994 to that in 2000?
Ensure brevity in your answer.  1.46. What is the ratio of the Exports(as % of merchandise exports) in Uganda in 1994 to that in 2000?
Your answer should be very brief. 1.31. What is the ratio of the Exports(as % of merchandise exports) in Mexico in 1995 to that in 1996?
Provide a succinct answer. 1.2. What is the ratio of the Exports(as % of merchandise exports) in Uganda in 1995 to that in 1996?
Ensure brevity in your answer.  1.16. What is the ratio of the Exports(as % of merchandise exports) of OECD members in 1995 to that in 1997?
Keep it short and to the point. 1.08. What is the ratio of the Exports(as % of merchandise exports) in Germany in 1995 to that in 1997?
Ensure brevity in your answer.  1.07. What is the ratio of the Exports(as % of merchandise exports) in Mexico in 1995 to that in 1997?
Your answer should be very brief. 1.25. What is the ratio of the Exports(as % of merchandise exports) in Uganda in 1995 to that in 1997?
Make the answer very short. 1.22. What is the ratio of the Exports(as % of merchandise exports) in OECD members in 1995 to that in 1998?
Make the answer very short. 1.12. What is the ratio of the Exports(as % of merchandise exports) in Germany in 1995 to that in 1998?
Your answer should be very brief. 1.07. What is the ratio of the Exports(as % of merchandise exports) of Mexico in 1995 to that in 1998?
Your answer should be very brief. 1.24. What is the ratio of the Exports(as % of merchandise exports) of Uganda in 1995 to that in 1998?
Offer a very short reply. 1.04. What is the ratio of the Exports(as % of merchandise exports) of OECD members in 1995 to that in 1999?
Offer a very short reply. 1.16. What is the ratio of the Exports(as % of merchandise exports) of Germany in 1995 to that in 1999?
Offer a terse response. 1.12. What is the ratio of the Exports(as % of merchandise exports) of Mexico in 1995 to that in 1999?
Give a very brief answer. 1.44. What is the ratio of the Exports(as % of merchandise exports) in Uganda in 1995 to that in 1999?
Your answer should be compact. 1.16. What is the ratio of the Exports(as % of merchandise exports) in OECD members in 1995 to that in 2000?
Ensure brevity in your answer.  1.33. What is the ratio of the Exports(as % of merchandise exports) in Germany in 1995 to that in 2000?
Give a very brief answer. 1.26. What is the ratio of the Exports(as % of merchandise exports) in Mexico in 1995 to that in 2000?
Offer a very short reply. 1.59. What is the ratio of the Exports(as % of merchandise exports) in Uganda in 1995 to that in 2000?
Make the answer very short. 1.27. What is the ratio of the Exports(as % of merchandise exports) of OECD members in 1996 to that in 1997?
Make the answer very short. 1.07. What is the ratio of the Exports(as % of merchandise exports) of Germany in 1996 to that in 1997?
Your answer should be compact. 1.07. What is the ratio of the Exports(as % of merchandise exports) of Mexico in 1996 to that in 1997?
Offer a terse response. 1.04. What is the ratio of the Exports(as % of merchandise exports) of Uganda in 1996 to that in 1997?
Offer a very short reply. 1.05. What is the ratio of the Exports(as % of merchandise exports) of OECD members in 1996 to that in 1998?
Offer a very short reply. 1.11. What is the ratio of the Exports(as % of merchandise exports) in Germany in 1996 to that in 1998?
Offer a very short reply. 1.07. What is the ratio of the Exports(as % of merchandise exports) of Mexico in 1996 to that in 1998?
Give a very brief answer. 1.04. What is the ratio of the Exports(as % of merchandise exports) of Uganda in 1996 to that in 1998?
Offer a terse response. 0.9. What is the ratio of the Exports(as % of merchandise exports) of OECD members in 1996 to that in 1999?
Give a very brief answer. 1.15. What is the ratio of the Exports(as % of merchandise exports) in Germany in 1996 to that in 1999?
Ensure brevity in your answer.  1.12. What is the ratio of the Exports(as % of merchandise exports) in Mexico in 1996 to that in 1999?
Ensure brevity in your answer.  1.2. What is the ratio of the Exports(as % of merchandise exports) of Uganda in 1996 to that in 1999?
Your answer should be compact. 1. What is the ratio of the Exports(as % of merchandise exports) of OECD members in 1996 to that in 2000?
Give a very brief answer. 1.32. What is the ratio of the Exports(as % of merchandise exports) of Germany in 1996 to that in 2000?
Keep it short and to the point. 1.26. What is the ratio of the Exports(as % of merchandise exports) of Mexico in 1996 to that in 2000?
Offer a terse response. 1.33. What is the ratio of the Exports(as % of merchandise exports) in Uganda in 1996 to that in 2000?
Keep it short and to the point. 1.09. What is the ratio of the Exports(as % of merchandise exports) of OECD members in 1997 to that in 1998?
Offer a terse response. 1.03. What is the ratio of the Exports(as % of merchandise exports) of Uganda in 1997 to that in 1998?
Keep it short and to the point. 0.86. What is the ratio of the Exports(as % of merchandise exports) of OECD members in 1997 to that in 1999?
Keep it short and to the point. 1.07. What is the ratio of the Exports(as % of merchandise exports) in Germany in 1997 to that in 1999?
Make the answer very short. 1.05. What is the ratio of the Exports(as % of merchandise exports) in Mexico in 1997 to that in 1999?
Make the answer very short. 1.15. What is the ratio of the Exports(as % of merchandise exports) in Uganda in 1997 to that in 1999?
Keep it short and to the point. 0.95. What is the ratio of the Exports(as % of merchandise exports) in OECD members in 1997 to that in 2000?
Keep it short and to the point. 1.23. What is the ratio of the Exports(as % of merchandise exports) in Germany in 1997 to that in 2000?
Your response must be concise. 1.18. What is the ratio of the Exports(as % of merchandise exports) in Mexico in 1997 to that in 2000?
Give a very brief answer. 1.27. What is the ratio of the Exports(as % of merchandise exports) in Uganda in 1997 to that in 2000?
Ensure brevity in your answer.  1.04. What is the ratio of the Exports(as % of merchandise exports) in OECD members in 1998 to that in 1999?
Offer a terse response. 1.04. What is the ratio of the Exports(as % of merchandise exports) in Germany in 1998 to that in 1999?
Your answer should be compact. 1.05. What is the ratio of the Exports(as % of merchandise exports) of Mexico in 1998 to that in 1999?
Your answer should be compact. 1.16. What is the ratio of the Exports(as % of merchandise exports) in Uganda in 1998 to that in 1999?
Ensure brevity in your answer.  1.11. What is the ratio of the Exports(as % of merchandise exports) of OECD members in 1998 to that in 2000?
Your answer should be compact. 1.19. What is the ratio of the Exports(as % of merchandise exports) in Germany in 1998 to that in 2000?
Keep it short and to the point. 1.18. What is the ratio of the Exports(as % of merchandise exports) of Mexico in 1998 to that in 2000?
Offer a very short reply. 1.28. What is the ratio of the Exports(as % of merchandise exports) in Uganda in 1998 to that in 2000?
Ensure brevity in your answer.  1.22. What is the ratio of the Exports(as % of merchandise exports) in Germany in 1999 to that in 2000?
Your answer should be very brief. 1.12. What is the ratio of the Exports(as % of merchandise exports) in Mexico in 1999 to that in 2000?
Provide a short and direct response. 1.11. What is the ratio of the Exports(as % of merchandise exports) in Uganda in 1999 to that in 2000?
Keep it short and to the point. 1.1. What is the difference between the highest and the second highest Exports(as % of merchandise exports) of OECD members?
Your answer should be very brief. 0.26. What is the difference between the highest and the second highest Exports(as % of merchandise exports) in Germany?
Provide a succinct answer. 0.15. What is the difference between the highest and the second highest Exports(as % of merchandise exports) in Mexico?
Keep it short and to the point. 0.64. What is the difference between the highest and the second highest Exports(as % of merchandise exports) of Uganda?
Offer a very short reply. 2.98. What is the difference between the highest and the lowest Exports(as % of merchandise exports) of OECD members?
Your answer should be compact. 2.54. What is the difference between the highest and the lowest Exports(as % of merchandise exports) of Germany?
Your answer should be compact. 1.22. What is the difference between the highest and the lowest Exports(as % of merchandise exports) of Mexico?
Your answer should be compact. 2.86. What is the difference between the highest and the lowest Exports(as % of merchandise exports) in Uganda?
Provide a short and direct response. 22.08. 